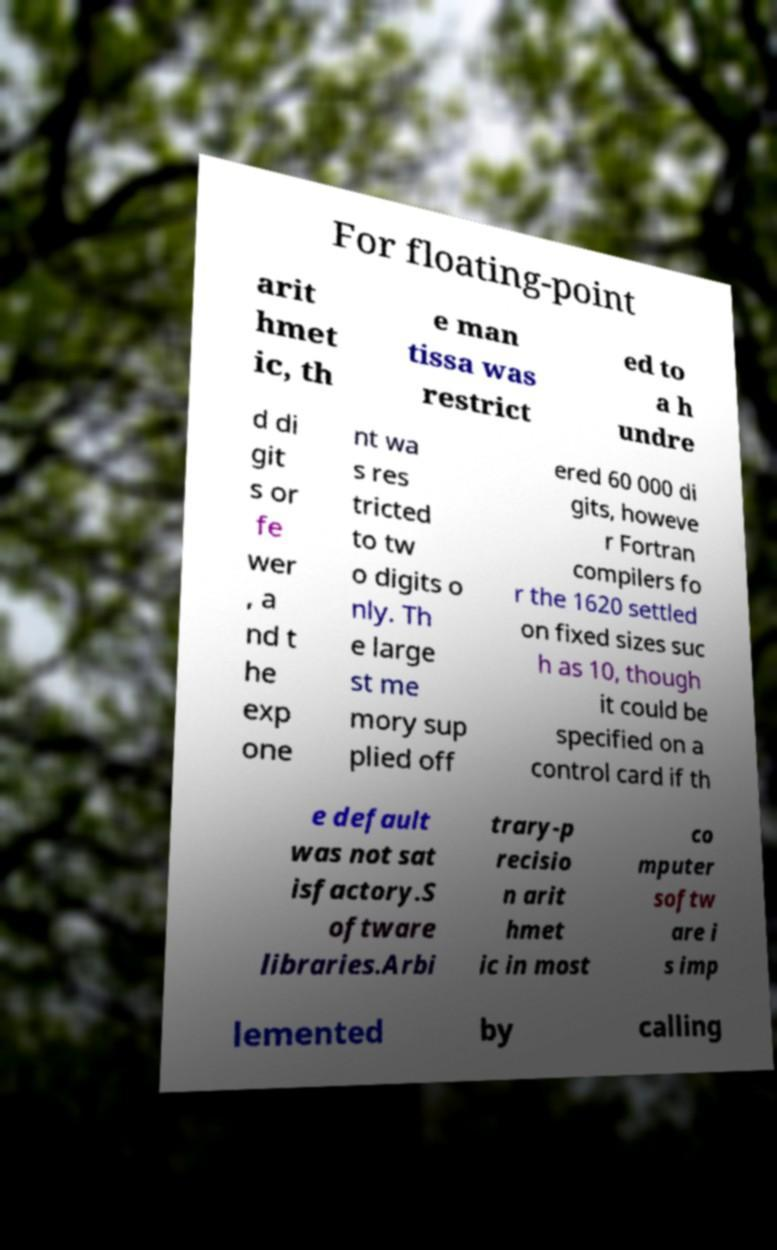I need the written content from this picture converted into text. Can you do that? For floating-point arit hmet ic, th e man tissa was restrict ed to a h undre d di git s or fe wer , a nd t he exp one nt wa s res tricted to tw o digits o nly. Th e large st me mory sup plied off ered 60 000 di gits, howeve r Fortran compilers fo r the 1620 settled on fixed sizes suc h as 10, though it could be specified on a control card if th e default was not sat isfactory.S oftware libraries.Arbi trary-p recisio n arit hmet ic in most co mputer softw are i s imp lemented by calling 